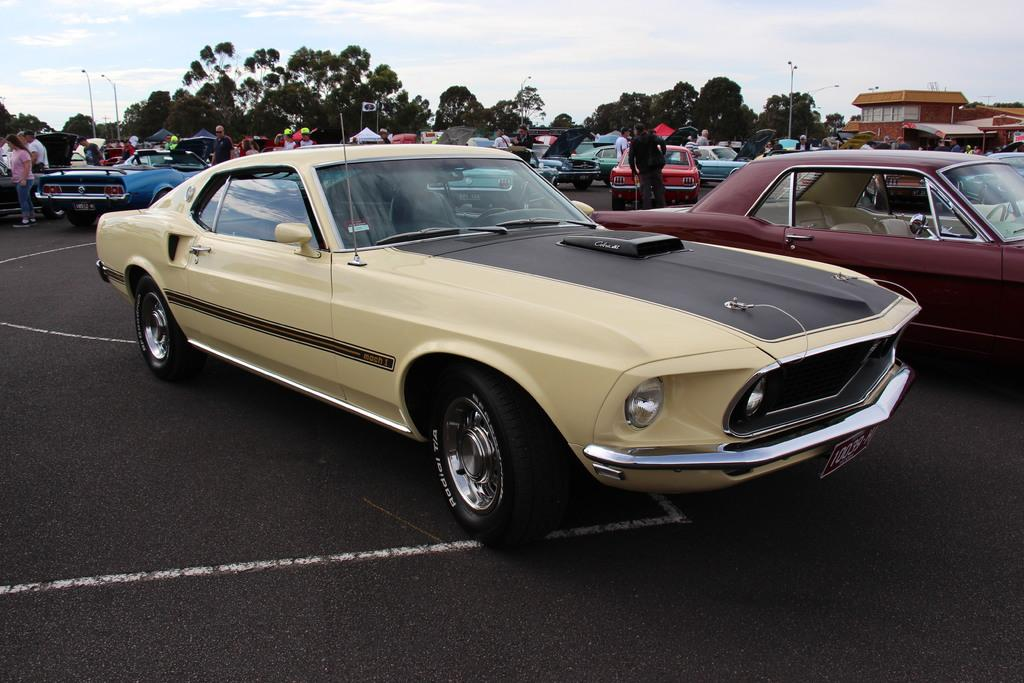What is parked on the road in the image? There is a car parked on the road in the image. What else can be seen in the background of the image? There are vehicles, people, stalls, buildings, street lights, trees, and the sky visible in the background. What type of cabbage is being sold at the stalls in the image? There is no cabbage present in the image; the stalls are not specified as selling any particular item. Can you see any deer in the image? There are no deer present in the image; the focus is on the car, background elements, and people. 